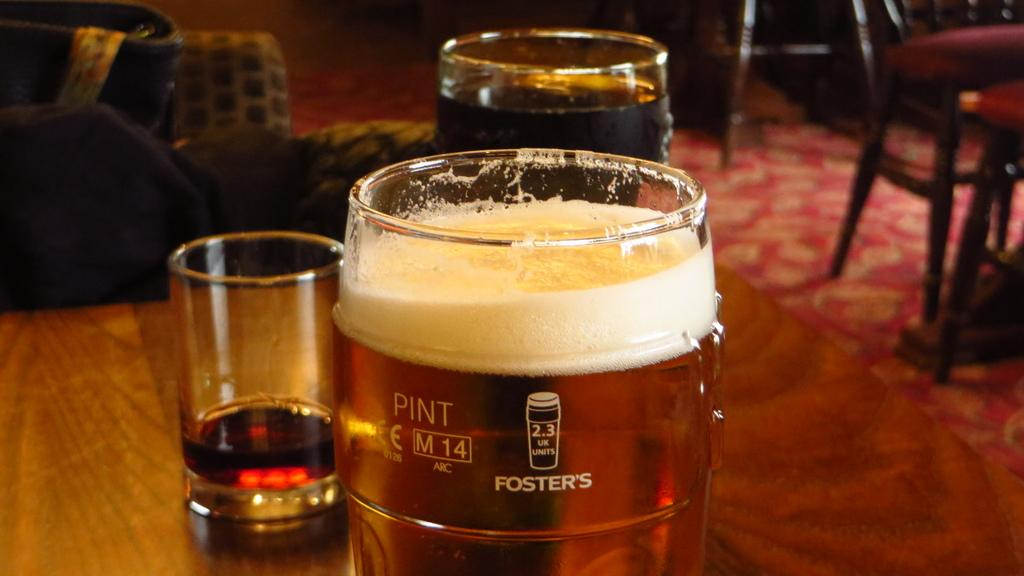<image>
Share a concise interpretation of the image provided. A pint of beer sitting on a wooden table with two other drinks in glasses in the background. 